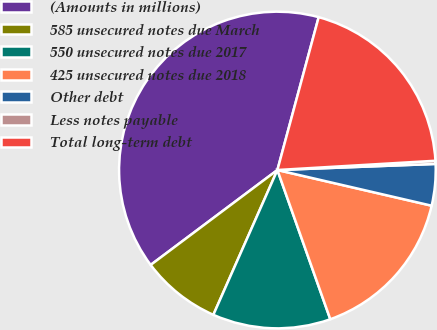Convert chart to OTSL. <chart><loc_0><loc_0><loc_500><loc_500><pie_chart><fcel>(Amounts in millions)<fcel>585 unsecured notes due March<fcel>550 unsecured notes due 2017<fcel>425 unsecured notes due 2018<fcel>Other debt<fcel>Less notes payable<fcel>Total long-term debt<nl><fcel>39.43%<fcel>8.14%<fcel>12.05%<fcel>15.96%<fcel>4.23%<fcel>0.32%<fcel>19.87%<nl></chart> 